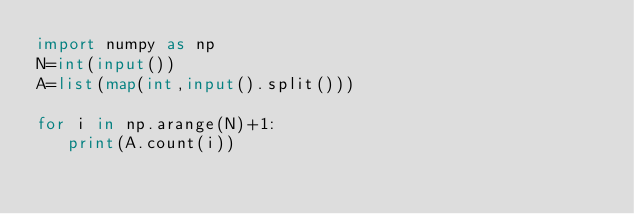<code> <loc_0><loc_0><loc_500><loc_500><_Python_>import numpy as np
N=int(input())
A=list(map(int,input().split()))

for i in np.arange(N)+1:
   print(A.count(i))
   </code> 